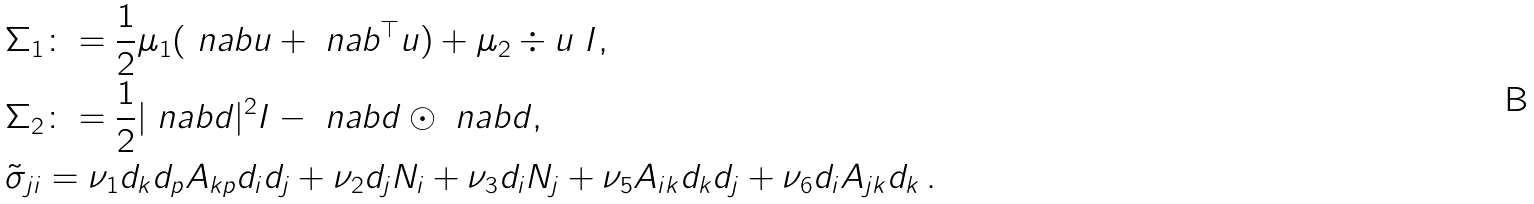Convert formula to latex. <formula><loc_0><loc_0><loc_500><loc_500>& \Sigma _ { 1 } \colon = \frac { 1 } { 2 } \mu _ { 1 } ( \ n a b u + \ n a b ^ { \top } u ) + \mu _ { 2 } \div u \ I , \\ & \Sigma _ { 2 } \colon = \frac { 1 } { 2 } | \ n a b d | ^ { 2 } I - \ n a b d \odot \ n a b d , \\ & \tilde { \sigma } _ { j i } = \nu _ { 1 } d _ { k } d _ { p } A _ { k p } d _ { i } d _ { j } + \nu _ { 2 } d _ { j } N _ { i } + \nu _ { 3 } d _ { i } N _ { j } + \nu _ { 5 } A _ { i k } d _ { k } d _ { j } + \nu _ { 6 } d _ { i } A _ { j k } d _ { k } \, .</formula> 